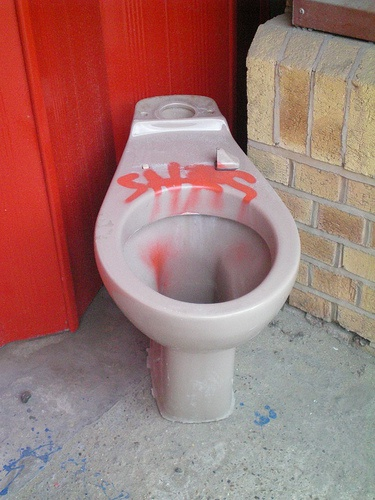Describe the objects in this image and their specific colors. I can see a toilet in brown, darkgray, lightgray, pink, and gray tones in this image. 